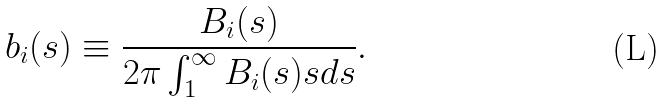Convert formula to latex. <formula><loc_0><loc_0><loc_500><loc_500>b _ { i } ( s ) \equiv \frac { B _ { i } ( s ) } { 2 \pi \int _ { 1 } ^ { \infty } B _ { i } ( s ) s d s } .</formula> 